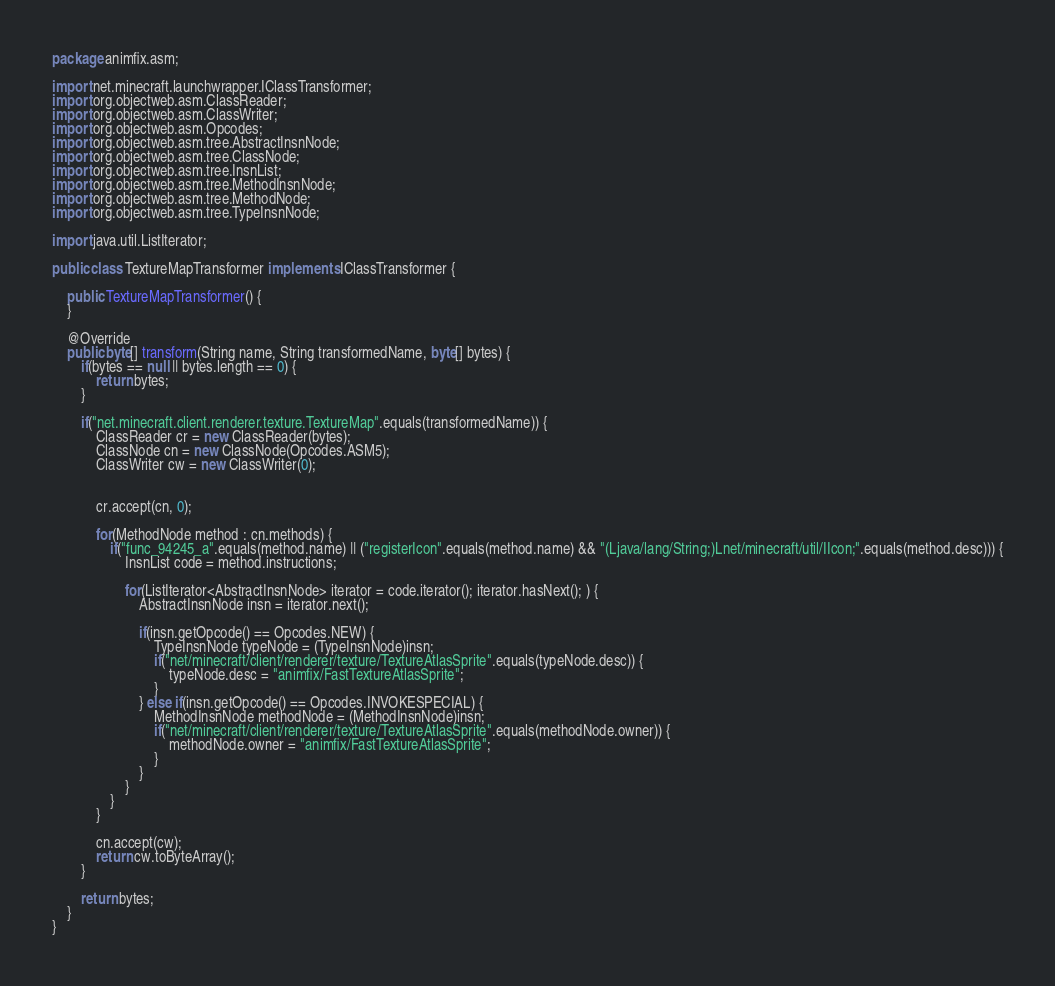<code> <loc_0><loc_0><loc_500><loc_500><_Java_>package animfix.asm;

import net.minecraft.launchwrapper.IClassTransformer;
import org.objectweb.asm.ClassReader;
import org.objectweb.asm.ClassWriter;
import org.objectweb.asm.Opcodes;
import org.objectweb.asm.tree.AbstractInsnNode;
import org.objectweb.asm.tree.ClassNode;
import org.objectweb.asm.tree.InsnList;
import org.objectweb.asm.tree.MethodInsnNode;
import org.objectweb.asm.tree.MethodNode;
import org.objectweb.asm.tree.TypeInsnNode;

import java.util.ListIterator;

public class TextureMapTransformer implements IClassTransformer {

    public TextureMapTransformer() {
    }

    @Override
    public byte[] transform(String name, String transformedName, byte[] bytes) {
        if(bytes == null || bytes.length == 0) {
            return bytes;
        }

        if("net.minecraft.client.renderer.texture.TextureMap".equals(transformedName)) {
            ClassReader cr = new ClassReader(bytes);
            ClassNode cn = new ClassNode(Opcodes.ASM5);
            ClassWriter cw = new ClassWriter(0);


            cr.accept(cn, 0);

            for(MethodNode method : cn.methods) {
                if("func_94245_a".equals(method.name) || ("registerIcon".equals(method.name) && "(Ljava/lang/String;)Lnet/minecraft/util/IIcon;".equals(method.desc))) {
                    InsnList code = method.instructions;

                    for(ListIterator<AbstractInsnNode> iterator = code.iterator(); iterator.hasNext(); ) {
                        AbstractInsnNode insn = iterator.next();

                        if(insn.getOpcode() == Opcodes.NEW) {
                            TypeInsnNode typeNode = (TypeInsnNode)insn;
                            if("net/minecraft/client/renderer/texture/TextureAtlasSprite".equals(typeNode.desc)) {
                                typeNode.desc = "animfix/FastTextureAtlasSprite";
                            }
                        } else if(insn.getOpcode() == Opcodes.INVOKESPECIAL) {
                            MethodInsnNode methodNode = (MethodInsnNode)insn;
                            if("net/minecraft/client/renderer/texture/TextureAtlasSprite".equals(methodNode.owner)) {
                                methodNode.owner = "animfix/FastTextureAtlasSprite";
                            }
                        }
                    }
                }
            }

            cn.accept(cw);
            return cw.toByteArray();
        }

        return bytes;
    }
}
</code> 